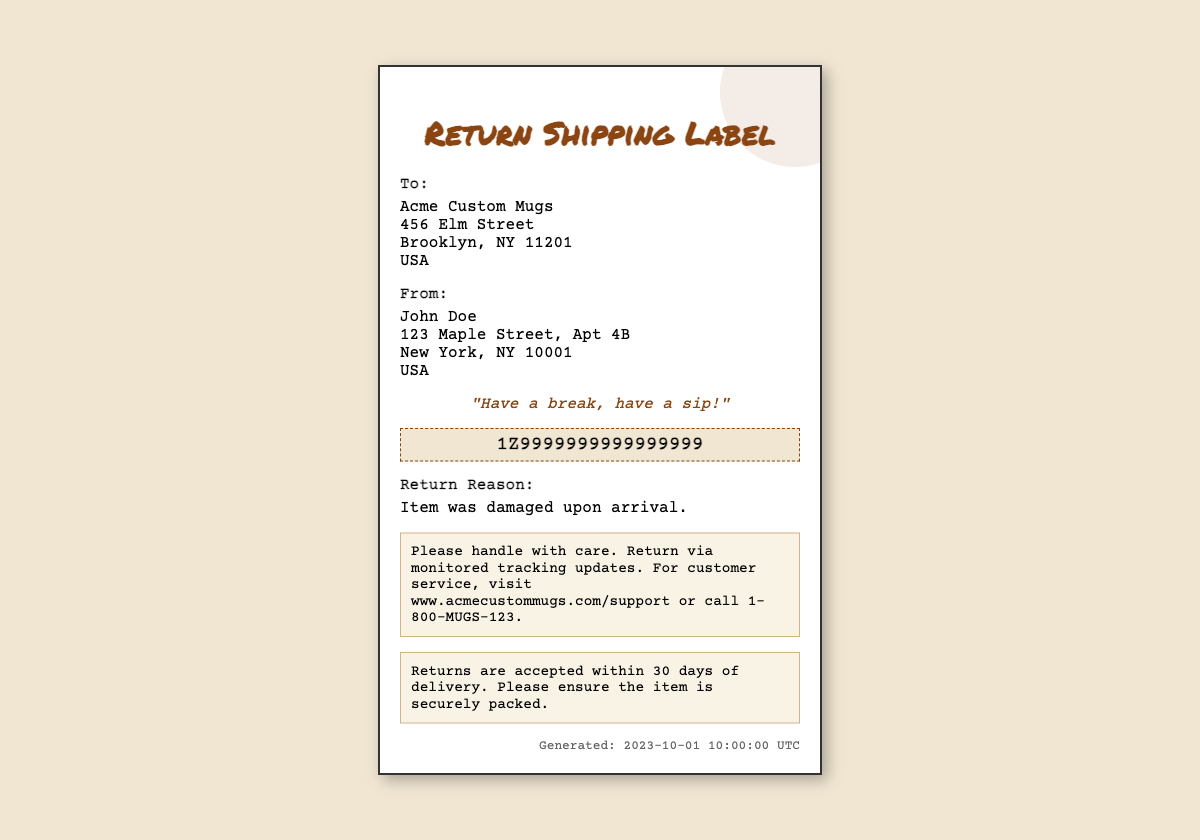What is the return reason? The document states that the item was damaged upon arrival, which is the reason for the return.
Answer: Item was damaged upon arrival What is the tracking number? The tracking number provided in the document is a unique identifier used for monitoring the return package.
Answer: 1Z9999999999999999 Who is the sender of the return package? The document lists John Doe as the sender, providing his full address in the 'From:' section.
Answer: John Doe What is the recipient's address? The document contains an address for Acme Custom Mugs, which is listed under the 'To:' section.
Answer: 456 Elm Street, Brooklyn, NY 11201, USA What is the generated date of the shipping label? The timestamp at the bottom of the document indicates when the shipping label was created.
Answer: 2023-10-01 10:00:00 UTC What should you do if you need customer service? The document provides a specific web address and phone number for customer support inquiries.
Answer: www.acmecustommugs.com/support or call 1-800-MUGS-123 What is the return policy duration? The return policy mentioned in the document states the time frame within which returns are accepted.
Answer: 30 days What style is the tagline written in? The document indicates that the tagline is presented in an italic font style to enhance its significance.
Answer: Italic What is emphasized in the return instructions? The instructions section highlights the importance of handling the return package with care during the shipping process.
Answer: Handle with care 